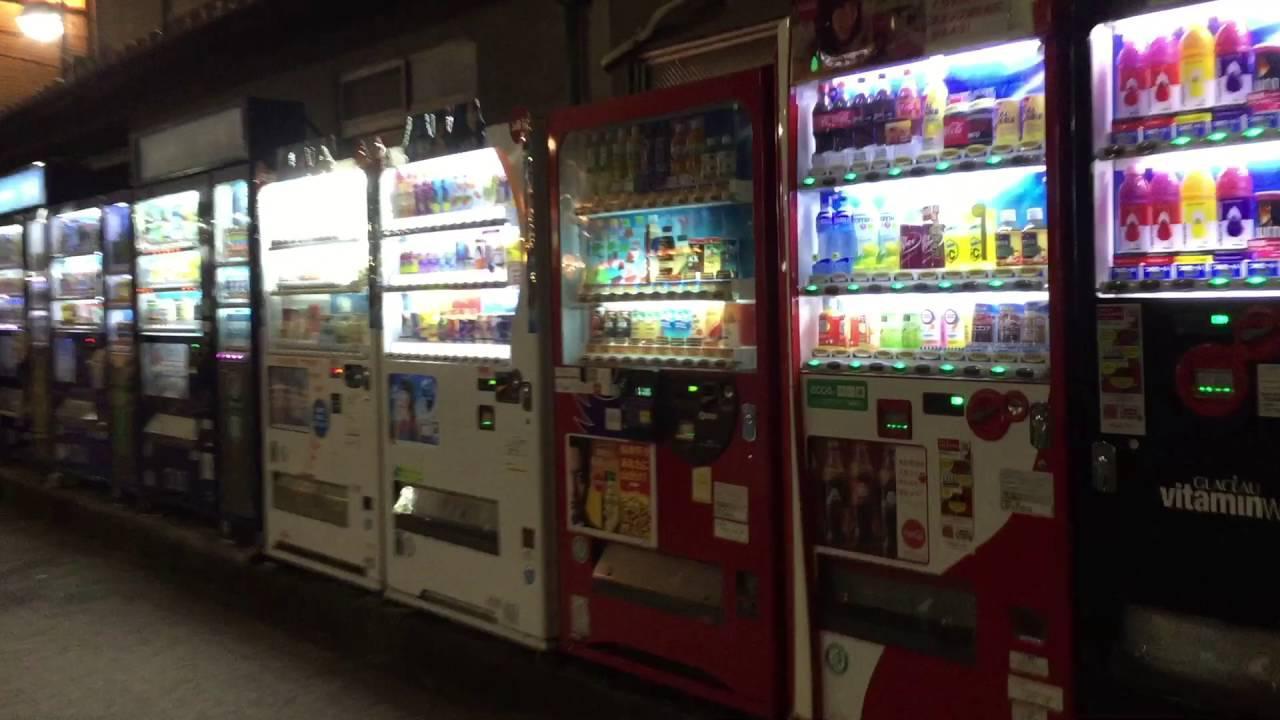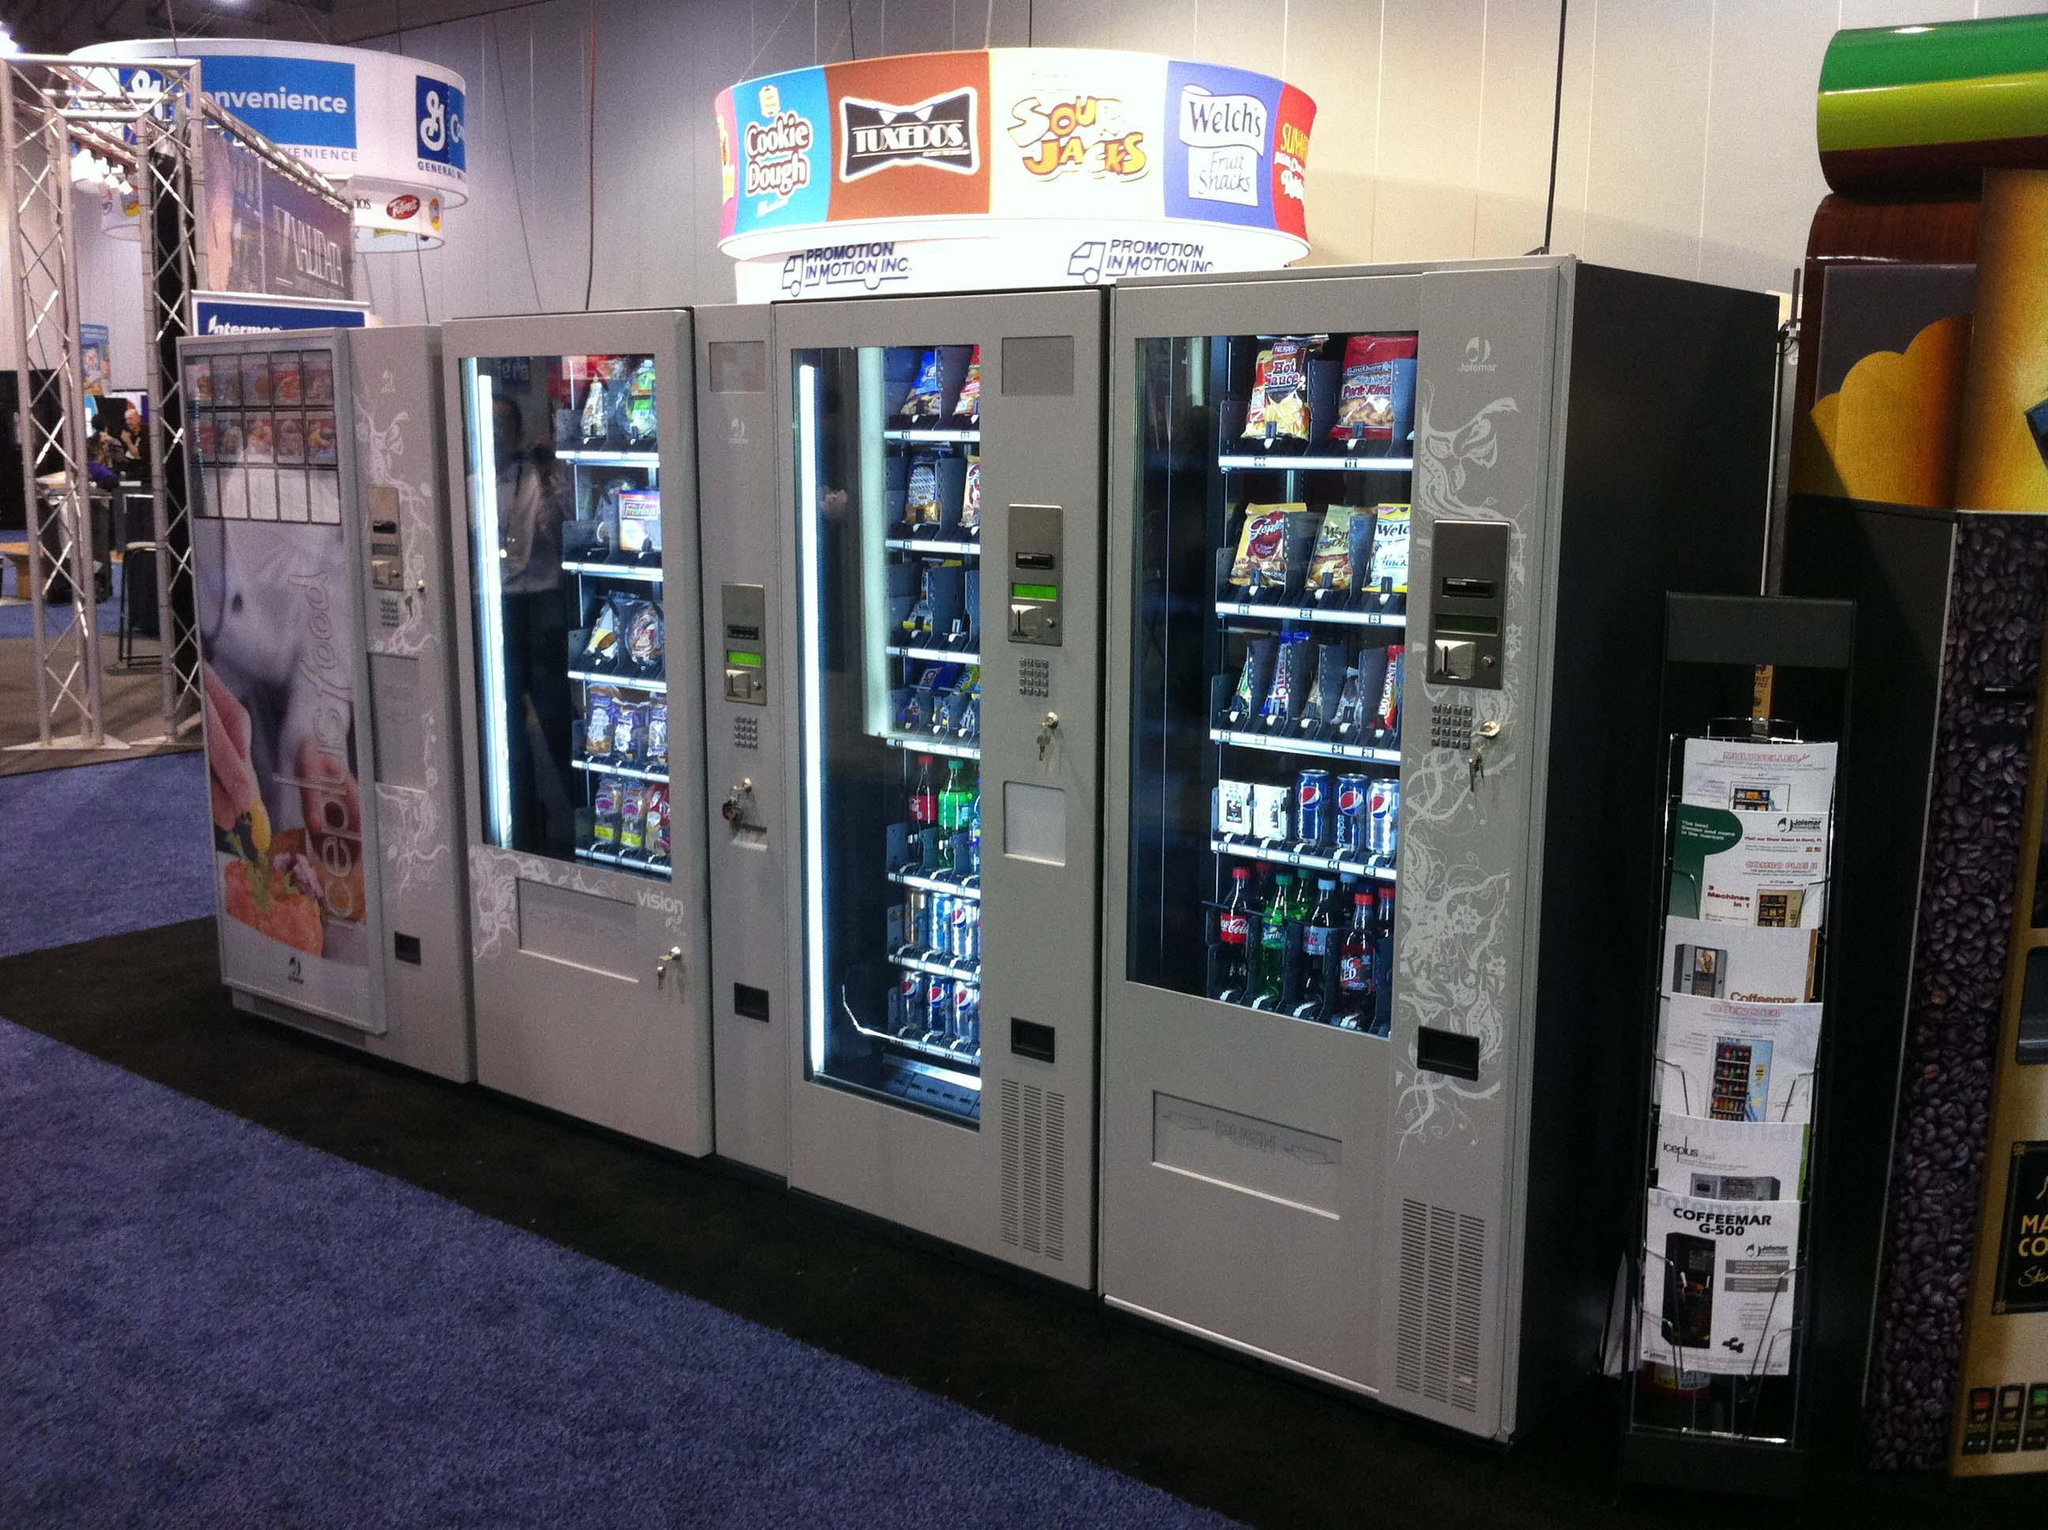The first image is the image on the left, the second image is the image on the right. Assess this claim about the two images: "One of the images clearly shows a blue vending machine placed directly next to a red vending machine.". Correct or not? Answer yes or no. No. The first image is the image on the left, the second image is the image on the right. Assess this claim about the two images: "A blue vending machine and a red vending machine are side by side.". Correct or not? Answer yes or no. No. 